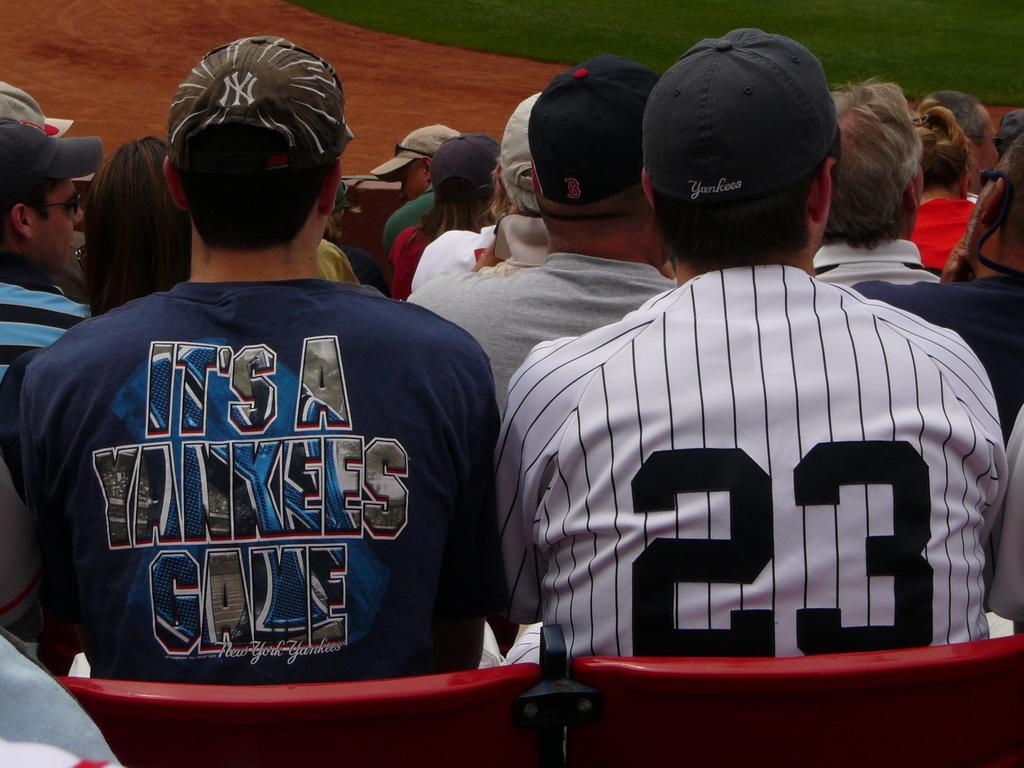Provide a one-sentence caption for the provided image. Two Yankees fans sit next to each other. 